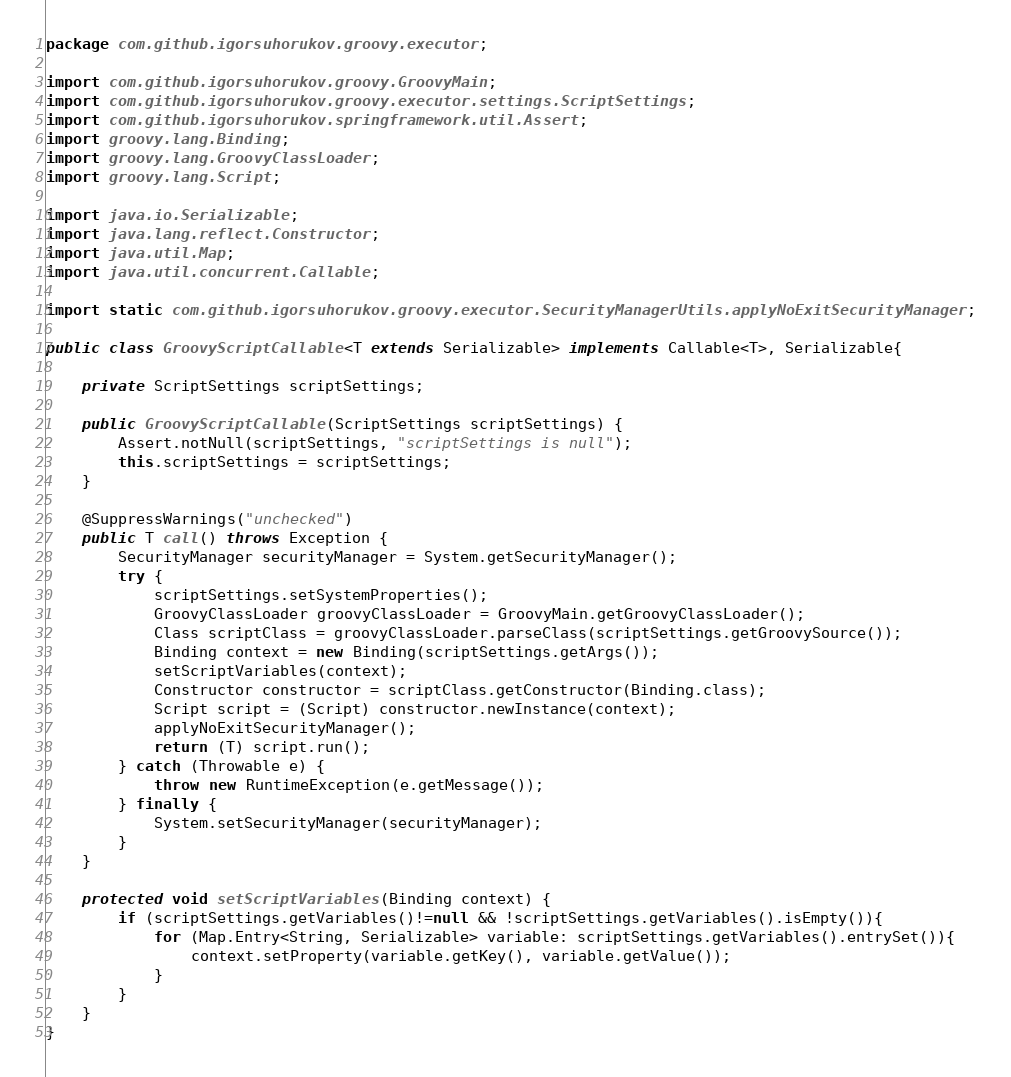<code> <loc_0><loc_0><loc_500><loc_500><_Java_>package com.github.igorsuhorukov.groovy.executor;

import com.github.igorsuhorukov.groovy.GroovyMain;
import com.github.igorsuhorukov.groovy.executor.settings.ScriptSettings;
import com.github.igorsuhorukov.springframework.util.Assert;
import groovy.lang.Binding;
import groovy.lang.GroovyClassLoader;
import groovy.lang.Script;

import java.io.Serializable;
import java.lang.reflect.Constructor;
import java.util.Map;
import java.util.concurrent.Callable;

import static com.github.igorsuhorukov.groovy.executor.SecurityManagerUtils.applyNoExitSecurityManager;

public class GroovyScriptCallable<T extends Serializable> implements Callable<T>, Serializable{

    private ScriptSettings scriptSettings;

    public GroovyScriptCallable(ScriptSettings scriptSettings) {
        Assert.notNull(scriptSettings, "scriptSettings is null");
        this.scriptSettings = scriptSettings;
    }

    @SuppressWarnings("unchecked")
    public T call() throws Exception {
        SecurityManager securityManager = System.getSecurityManager();
        try {
            scriptSettings.setSystemProperties();
            GroovyClassLoader groovyClassLoader = GroovyMain.getGroovyClassLoader();
            Class scriptClass = groovyClassLoader.parseClass(scriptSettings.getGroovySource());
            Binding context = new Binding(scriptSettings.getArgs());
            setScriptVariables(context);
            Constructor constructor = scriptClass.getConstructor(Binding.class);
            Script script = (Script) constructor.newInstance(context);
            applyNoExitSecurityManager();
            return (T) script.run();
        } catch (Throwable e) {
            throw new RuntimeException(e.getMessage());
        } finally {
            System.setSecurityManager(securityManager);
        }
    }

    protected void setScriptVariables(Binding context) {
        if (scriptSettings.getVariables()!=null && !scriptSettings.getVariables().isEmpty()){
            for (Map.Entry<String, Serializable> variable: scriptSettings.getVariables().entrySet()){
                context.setProperty(variable.getKey(), variable.getValue());
            }
        }
    }
}
</code> 